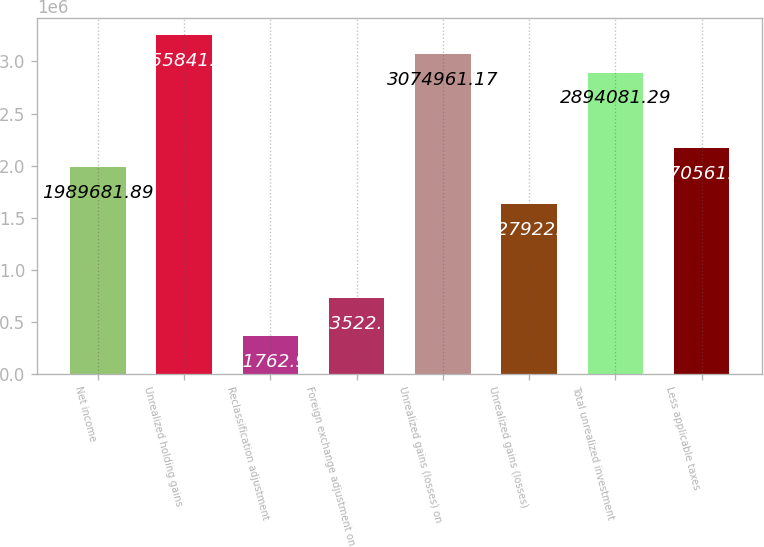Convert chart to OTSL. <chart><loc_0><loc_0><loc_500><loc_500><bar_chart><fcel>Net income<fcel>Unrealized holding gains<fcel>Reclassification adjustment<fcel>Foreign exchange adjustment on<fcel>Unrealized gains (losses) on<fcel>Unrealized gains (losses)<fcel>Total unrealized investment<fcel>Less applicable taxes<nl><fcel>1.98968e+06<fcel>3.25584e+06<fcel>361763<fcel>723523<fcel>3.07496e+06<fcel>1.62792e+06<fcel>2.89408e+06<fcel>2.17056e+06<nl></chart> 